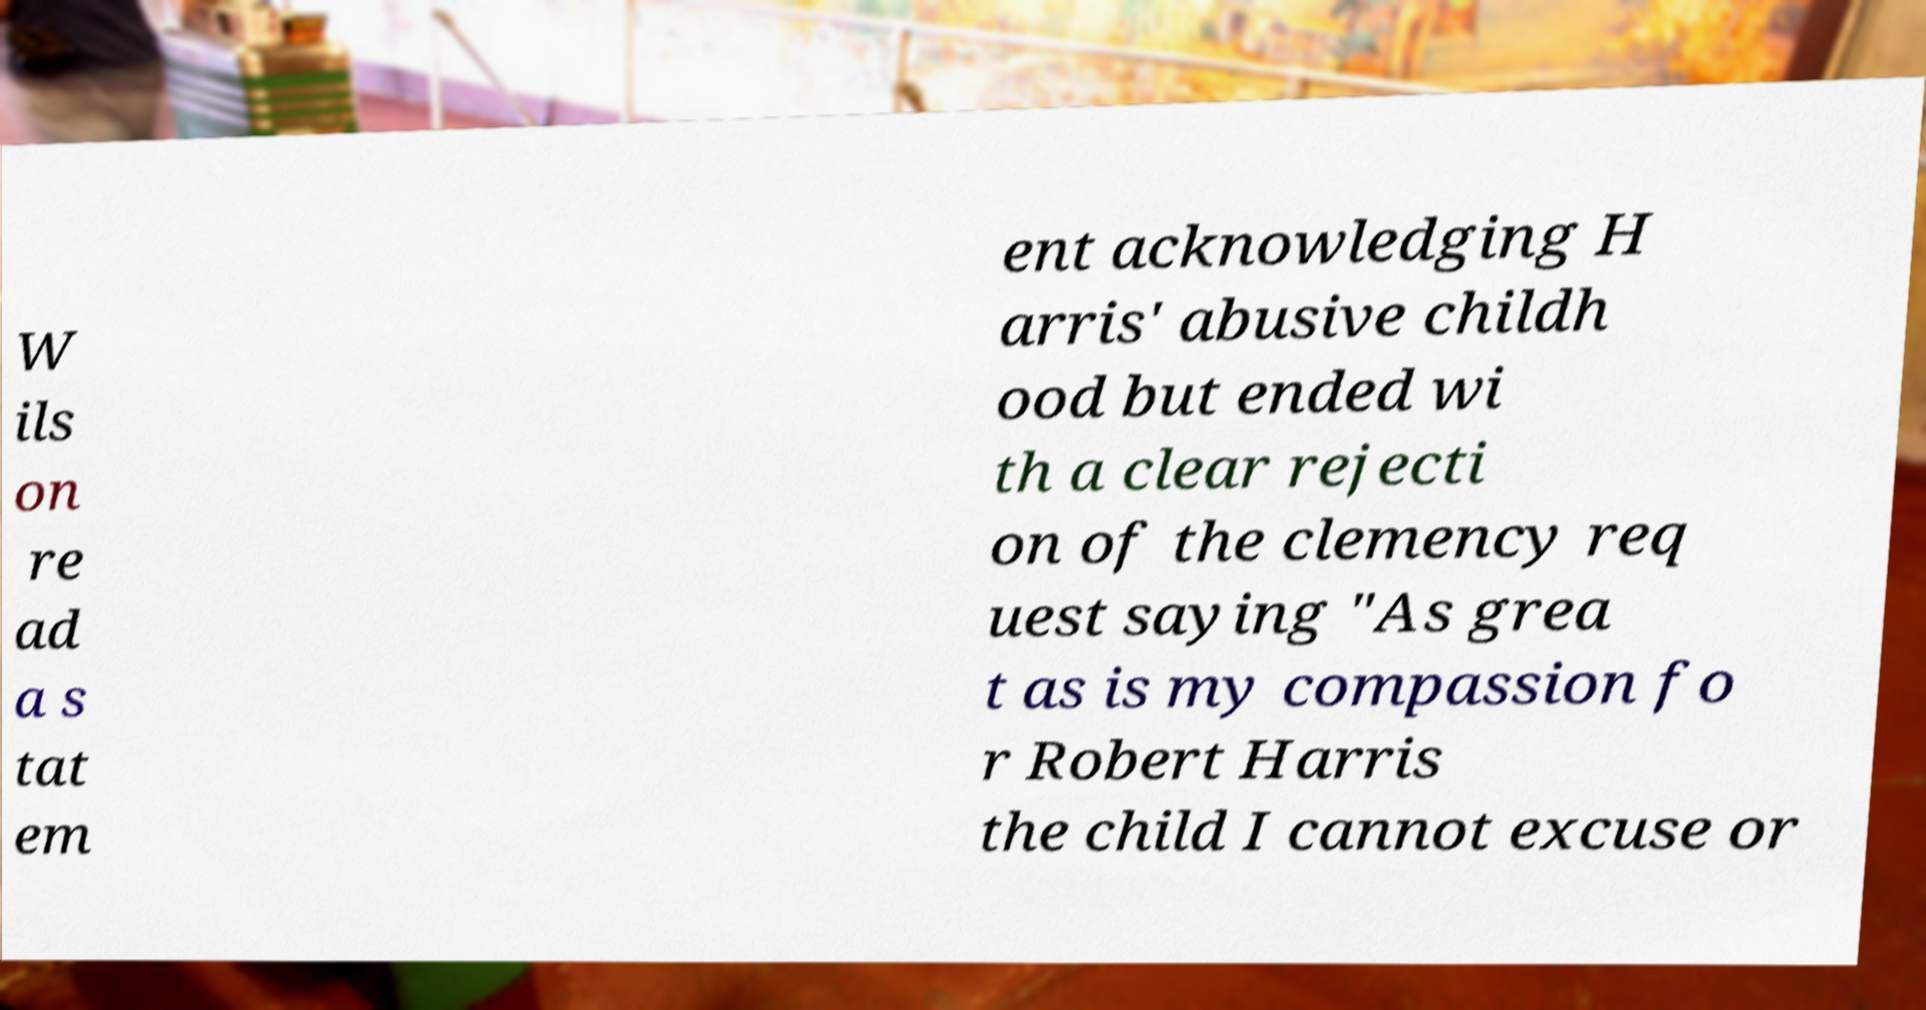What messages or text are displayed in this image? I need them in a readable, typed format. W ils on re ad a s tat em ent acknowledging H arris' abusive childh ood but ended wi th a clear rejecti on of the clemency req uest saying "As grea t as is my compassion fo r Robert Harris the child I cannot excuse or 